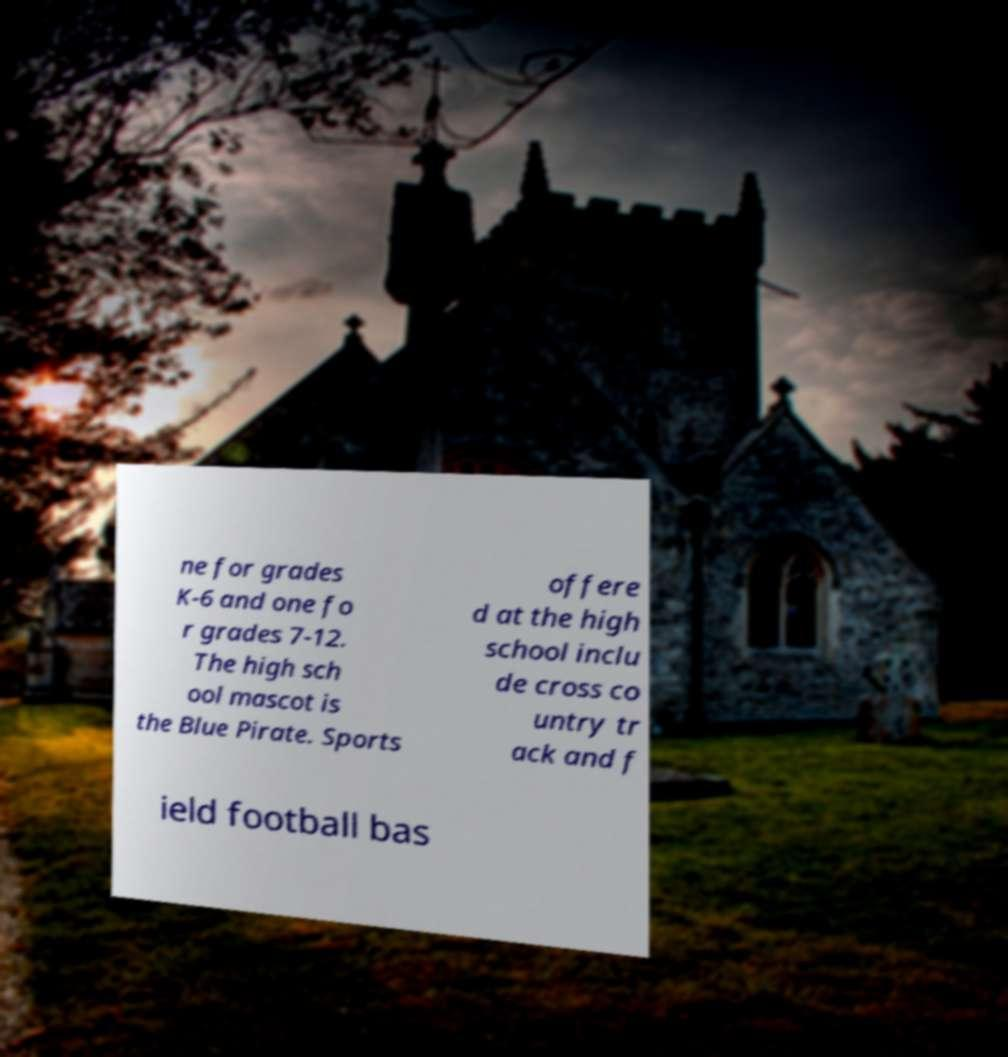Could you extract and type out the text from this image? ne for grades K-6 and one fo r grades 7-12. The high sch ool mascot is the Blue Pirate. Sports offere d at the high school inclu de cross co untry tr ack and f ield football bas 